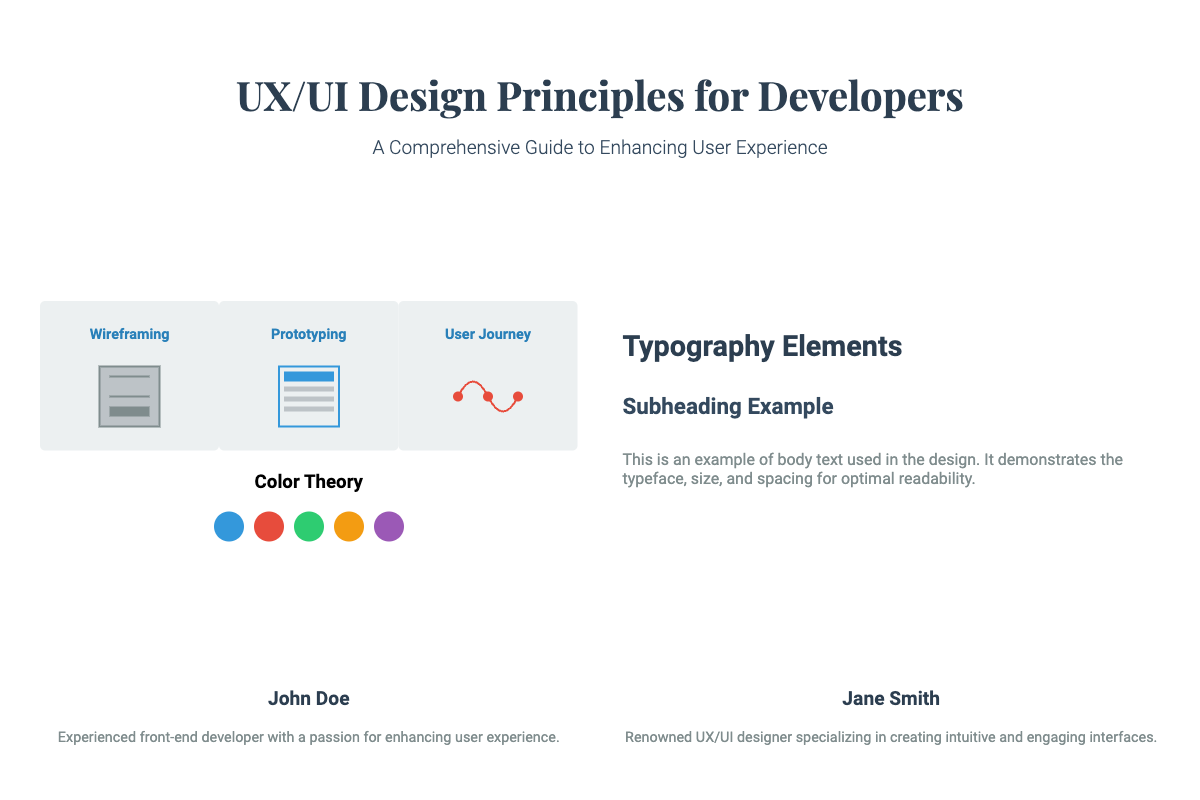What is the title of the book? The title of the book is prominently displayed at the top of the cover.
Answer: UX/UI Design Principles for Developers Who are the authors of the book? The authors' names are listed at the bottom of the cover.
Answer: John Doe, Jane Smith What stage comes after wireframing? The stages of design are listed in the left column.
Answer: Prototyping How many colors are shown in the color theory section? The color palette consists of multiple color swatches presented together.
Answer: Five What is the main focus of the typography section? The typography section provides insights into typeface and readability for designs.
Answer: Typography Elements What color is used for the first stage of wireframing? The specific color used for the wireframing stage is indicated in the design stage box.
Answer: Light Gray What feature distinguishes the authors' text boxes? The layout of author information is organized into separate text boxes.
Answer: Two columns What is the subtitle of the book? The subtitle is presented directly under the title, providing additional context.
Answer: A Comprehensive Guide to Enhancing User Experience 